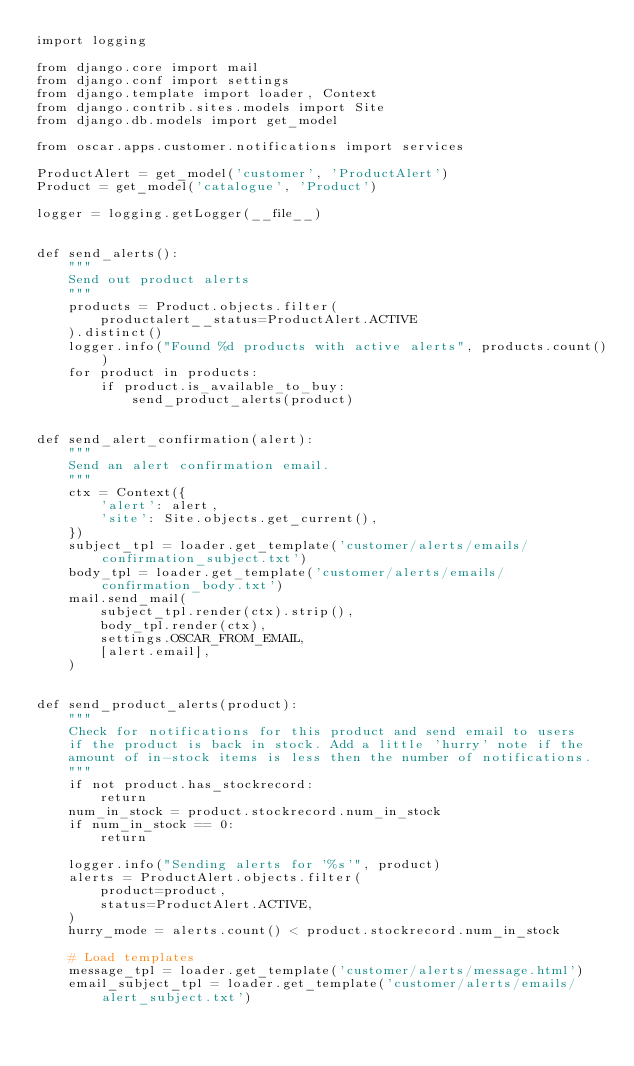Convert code to text. <code><loc_0><loc_0><loc_500><loc_500><_Python_>import logging

from django.core import mail
from django.conf import settings
from django.template import loader, Context
from django.contrib.sites.models import Site
from django.db.models import get_model

from oscar.apps.customer.notifications import services

ProductAlert = get_model('customer', 'ProductAlert')
Product = get_model('catalogue', 'Product')

logger = logging.getLogger(__file__)


def send_alerts():
    """
    Send out product alerts
    """
    products = Product.objects.filter(
        productalert__status=ProductAlert.ACTIVE
    ).distinct()
    logger.info("Found %d products with active alerts", products.count())
    for product in products:
        if product.is_available_to_buy:
            send_product_alerts(product)


def send_alert_confirmation(alert):
    """
    Send an alert confirmation email.
    """
    ctx = Context({
        'alert': alert,
        'site': Site.objects.get_current(),
    })
    subject_tpl = loader.get_template('customer/alerts/emails/confirmation_subject.txt')
    body_tpl = loader.get_template('customer/alerts/emails/confirmation_body.txt')
    mail.send_mail(
        subject_tpl.render(ctx).strip(),
        body_tpl.render(ctx),
        settings.OSCAR_FROM_EMAIL,
        [alert.email],
    )


def send_product_alerts(product):
    """
    Check for notifications for this product and send email to users
    if the product is back in stock. Add a little 'hurry' note if the
    amount of in-stock items is less then the number of notifications.
    """
    if not product.has_stockrecord:
        return
    num_in_stock = product.stockrecord.num_in_stock
    if num_in_stock == 0:
        return

    logger.info("Sending alerts for '%s'", product)
    alerts = ProductAlert.objects.filter(
        product=product,
        status=ProductAlert.ACTIVE,
    )
    hurry_mode = alerts.count() < product.stockrecord.num_in_stock

    # Load templates
    message_tpl = loader.get_template('customer/alerts/message.html')
    email_subject_tpl = loader.get_template('customer/alerts/emails/alert_subject.txt')</code> 